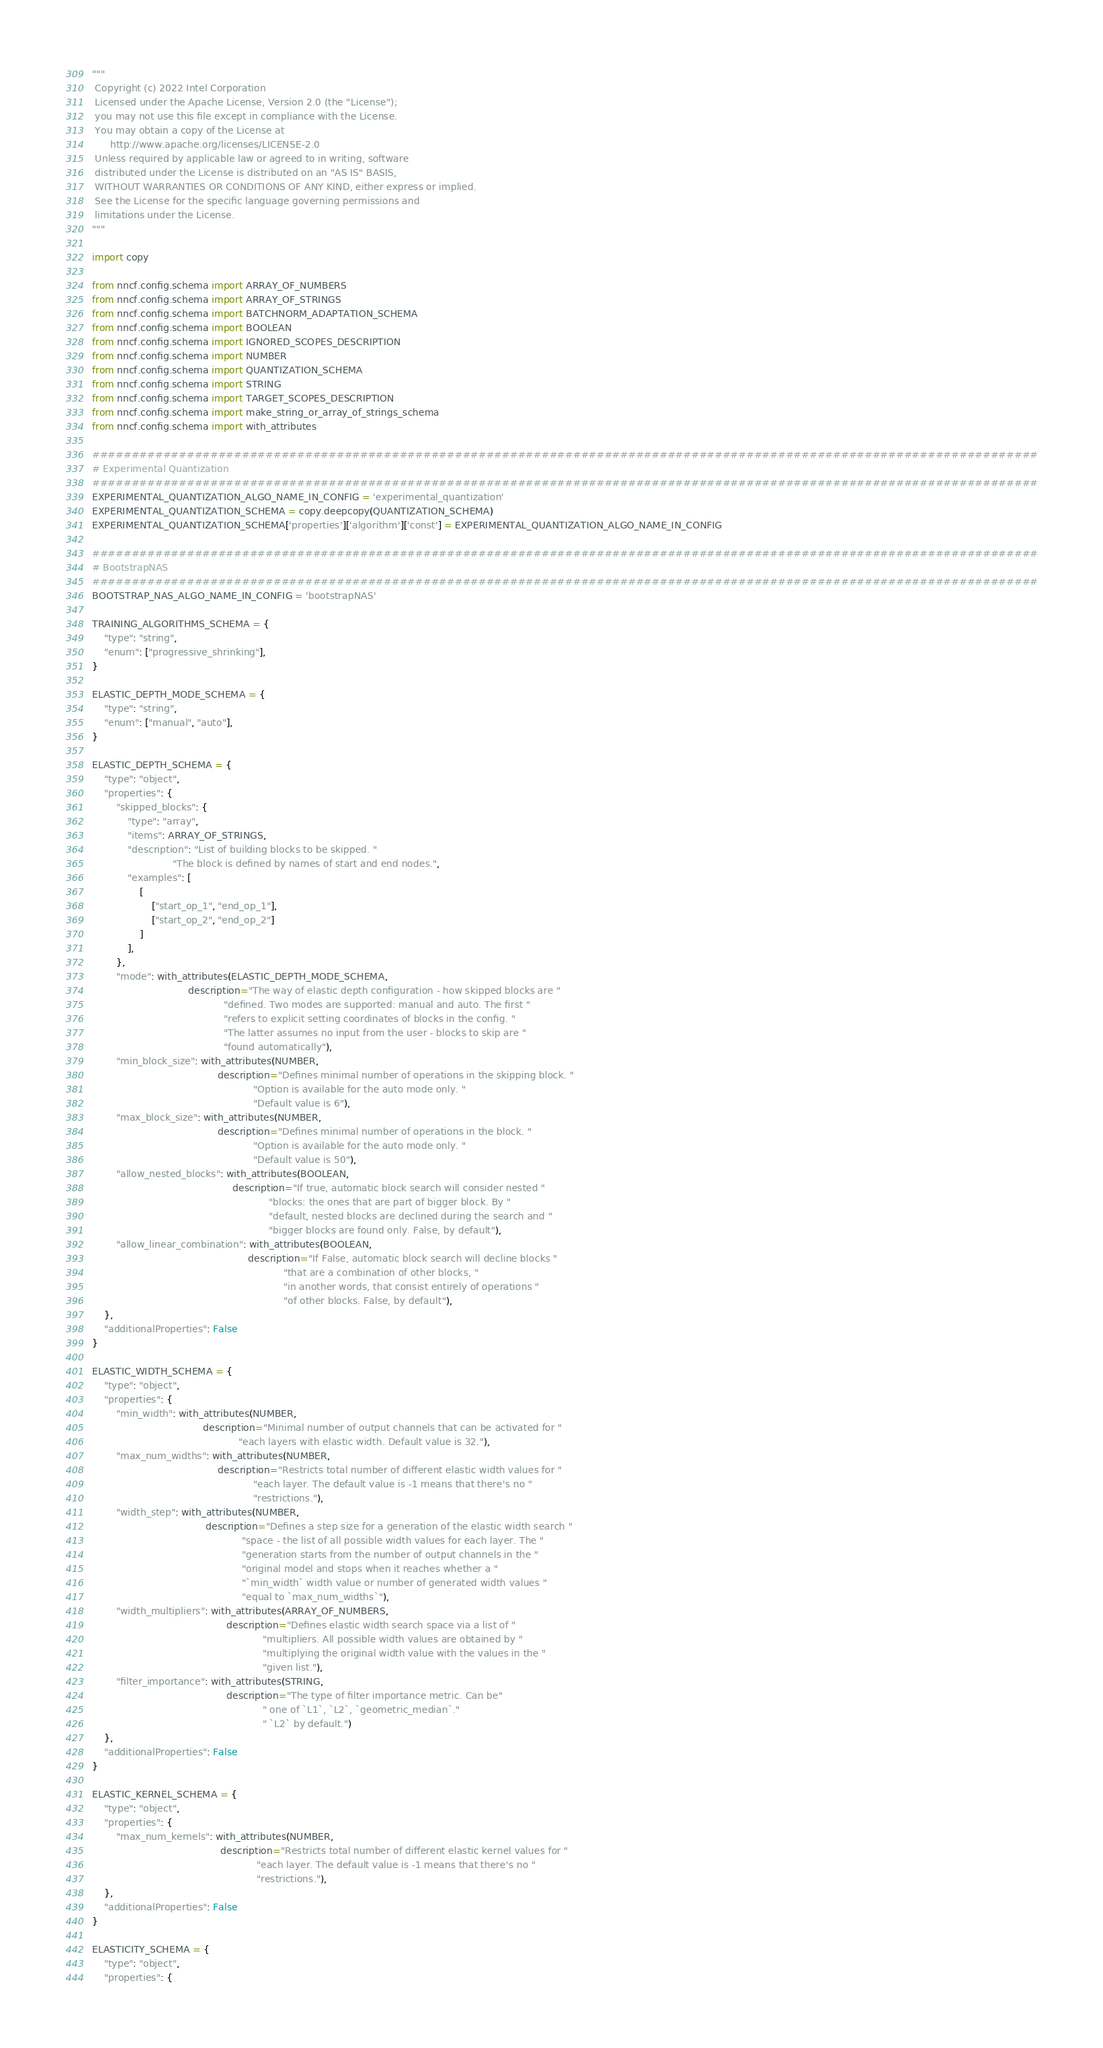<code> <loc_0><loc_0><loc_500><loc_500><_Python_>"""
 Copyright (c) 2022 Intel Corporation
 Licensed under the Apache License, Version 2.0 (the "License");
 you may not use this file except in compliance with the License.
 You may obtain a copy of the License at
      http://www.apache.org/licenses/LICENSE-2.0
 Unless required by applicable law or agreed to in writing, software
 distributed under the License is distributed on an "AS IS" BASIS,
 WITHOUT WARRANTIES OR CONDITIONS OF ANY KIND, either express or implied.
 See the License for the specific language governing permissions and
 limitations under the License.
"""

import copy

from nncf.config.schema import ARRAY_OF_NUMBERS
from nncf.config.schema import ARRAY_OF_STRINGS
from nncf.config.schema import BATCHNORM_ADAPTATION_SCHEMA
from nncf.config.schema import BOOLEAN
from nncf.config.schema import IGNORED_SCOPES_DESCRIPTION
from nncf.config.schema import NUMBER
from nncf.config.schema import QUANTIZATION_SCHEMA
from nncf.config.schema import STRING
from nncf.config.schema import TARGET_SCOPES_DESCRIPTION
from nncf.config.schema import make_string_or_array_of_strings_schema
from nncf.config.schema import with_attributes

########################################################################################################################
# Experimental Quantization
########################################################################################################################
EXPERIMENTAL_QUANTIZATION_ALGO_NAME_IN_CONFIG = 'experimental_quantization'
EXPERIMENTAL_QUANTIZATION_SCHEMA = copy.deepcopy(QUANTIZATION_SCHEMA)
EXPERIMENTAL_QUANTIZATION_SCHEMA['properties']['algorithm']['const'] = EXPERIMENTAL_QUANTIZATION_ALGO_NAME_IN_CONFIG

########################################################################################################################
# BootstrapNAS
########################################################################################################################
BOOTSTRAP_NAS_ALGO_NAME_IN_CONFIG = 'bootstrapNAS'

TRAINING_ALGORITHMS_SCHEMA = {
    "type": "string",
    "enum": ["progressive_shrinking"],
}

ELASTIC_DEPTH_MODE_SCHEMA = {
    "type": "string",
    "enum": ["manual", "auto"],
}

ELASTIC_DEPTH_SCHEMA = {
    "type": "object",
    "properties": {
        "skipped_blocks": {
            "type": "array",
            "items": ARRAY_OF_STRINGS,
            "description": "List of building blocks to be skipped. "
                           "The block is defined by names of start and end nodes.",
            "examples": [
                [
                    ["start_op_1", "end_op_1"],
                    ["start_op_2", "end_op_2"]
                ]
            ],
        },
        "mode": with_attributes(ELASTIC_DEPTH_MODE_SCHEMA,
                                description="The way of elastic depth configuration - how skipped blocks are "
                                            "defined. Two modes are supported: manual and auto. The first "
                                            "refers to explicit setting coordinates of blocks in the config. "
                                            "The latter assumes no input from the user - blocks to skip are "
                                            "found automatically"),
        "min_block_size": with_attributes(NUMBER,
                                          description="Defines minimal number of operations in the skipping block. "
                                                      "Option is available for the auto mode only. "
                                                      "Default value is 6"),
        "max_block_size": with_attributes(NUMBER,
                                          description="Defines minimal number of operations in the block. "
                                                      "Option is available for the auto mode only. "
                                                      "Default value is 50"),
        "allow_nested_blocks": with_attributes(BOOLEAN,
                                               description="If true, automatic block search will consider nested "
                                                           "blocks: the ones that are part of bigger block. By "
                                                           "default, nested blocks are declined during the search and "
                                                           "bigger blocks are found only. False, by default"),
        "allow_linear_combination": with_attributes(BOOLEAN,
                                                    description="If False, automatic block search will decline blocks "
                                                                "that are a combination of other blocks, "
                                                                "in another words, that consist entirely of operations "
                                                                "of other blocks. False, by default"),
    },
    "additionalProperties": False
}

ELASTIC_WIDTH_SCHEMA = {
    "type": "object",
    "properties": {
        "min_width": with_attributes(NUMBER,
                                     description="Minimal number of output channels that can be activated for "
                                                 "each layers with elastic width. Default value is 32."),
        "max_num_widths": with_attributes(NUMBER,
                                          description="Restricts total number of different elastic width values for "
                                                      "each layer. The default value is -1 means that there's no "
                                                      "restrictions."),
        "width_step": with_attributes(NUMBER,
                                      description="Defines a step size for a generation of the elastic width search "
                                                  "space - the list of all possible width values for each layer. The "
                                                  "generation starts from the number of output channels in the "
                                                  "original model and stops when it reaches whether a "
                                                  "`min_width` width value or number of generated width values "
                                                  "equal to `max_num_widths`"),
        "width_multipliers": with_attributes(ARRAY_OF_NUMBERS,
                                             description="Defines elastic width search space via a list of "
                                                         "multipliers. All possible width values are obtained by "
                                                         "multiplying the original width value with the values in the "
                                                         "given list."),
        "filter_importance": with_attributes(STRING,
                                             description="The type of filter importance metric. Can be"
                                                         " one of `L1`, `L2`, `geometric_median`."
                                                         " `L2` by default.")
    },
    "additionalProperties": False
}

ELASTIC_KERNEL_SCHEMA = {
    "type": "object",
    "properties": {
        "max_num_kernels": with_attributes(NUMBER,
                                           description="Restricts total number of different elastic kernel values for "
                                                       "each layer. The default value is -1 means that there's no "
                                                       "restrictions."),
    },
    "additionalProperties": False
}

ELASTICITY_SCHEMA = {
    "type": "object",
    "properties": {</code> 